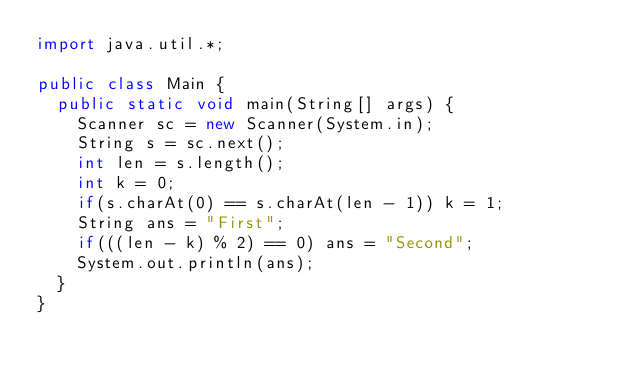<code> <loc_0><loc_0><loc_500><loc_500><_Java_>import java.util.*;

public class Main {
  public static void main(String[] args) {
    Scanner sc = new Scanner(System.in);
    String s = sc.next();
    int len = s.length();
    int k = 0;
    if(s.charAt(0) == s.charAt(len - 1)) k = 1;
    String ans = "First";
    if(((len - k) % 2) == 0) ans = "Second";
    System.out.println(ans);
  }
}</code> 